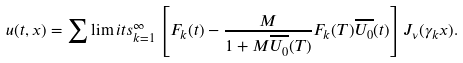<formula> <loc_0><loc_0><loc_500><loc_500>u ( t , x ) = \sum \lim i t s _ { k = 1 } ^ { \infty } \left [ F _ { k } ( t ) - \frac { M } { 1 + M \overline { U _ { 0 } } ( T ) } F _ { k } ( T ) \overline { U _ { 0 } } ( t ) \right ] J _ { \nu } ( \gamma _ { k } x ) .</formula> 